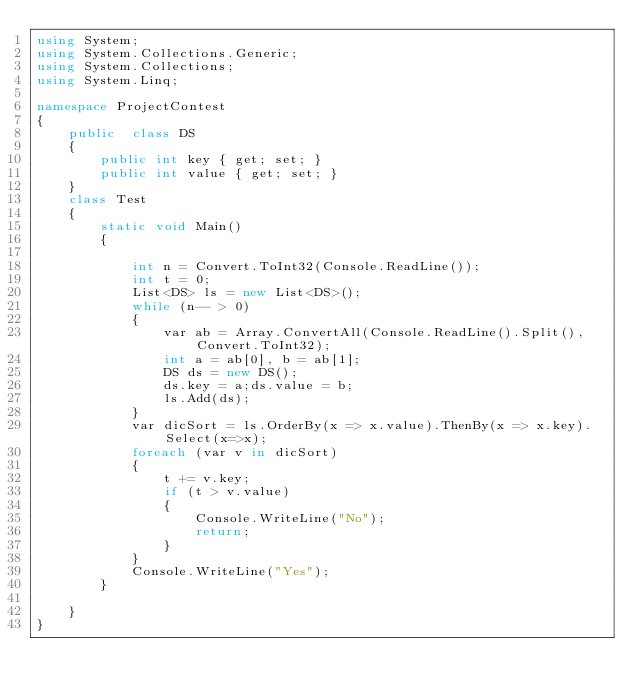<code> <loc_0><loc_0><loc_500><loc_500><_C#_>using System;
using System.Collections.Generic;
using System.Collections;
using System.Linq;

namespace ProjectContest
{
    public  class DS
    {
        public int key { get; set; }
        public int value { get; set; }
    }
    class Test
    {
        static void Main()
        {
            
            int n = Convert.ToInt32(Console.ReadLine());
            int t = 0;
            List<DS> ls = new List<DS>();
            while (n-- > 0)
            {
                var ab = Array.ConvertAll(Console.ReadLine().Split(), Convert.ToInt32);
                int a = ab[0], b = ab[1];
                DS ds = new DS();
                ds.key = a;ds.value = b;
                ls.Add(ds);
            }
            var dicSort = ls.OrderBy(x => x.value).ThenBy(x => x.key).Select(x=>x);
            foreach (var v in dicSort)
            {
                t += v.key;
                if (t > v.value)
                {
                    Console.WriteLine("No");
                    return;
                }
            }
            Console.WriteLine("Yes");
        }

    }
}</code> 